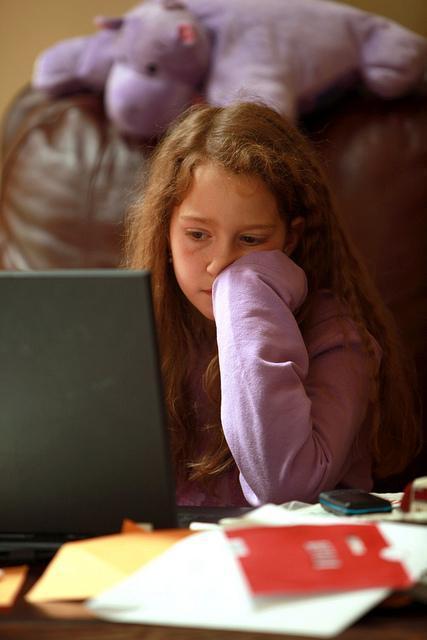Does the description: "The teddy bear is behind the person." accurately reflect the image?
Answer yes or no. Yes. 